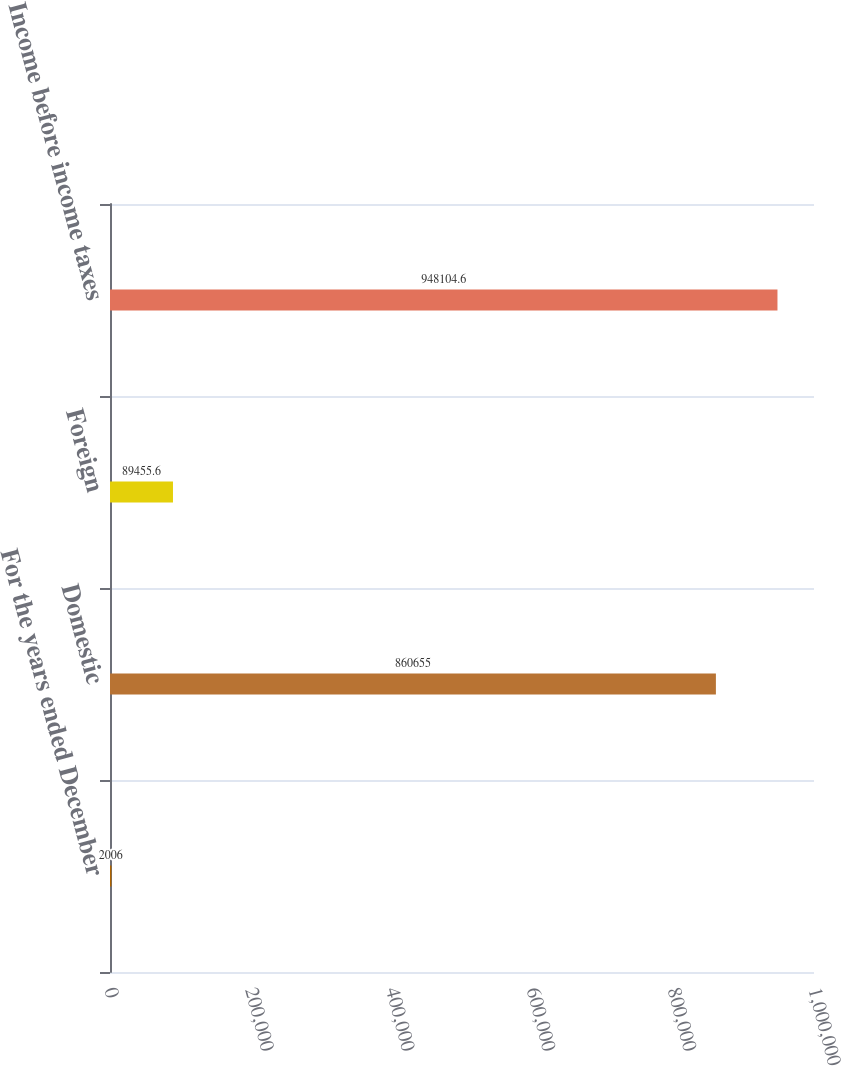Convert chart. <chart><loc_0><loc_0><loc_500><loc_500><bar_chart><fcel>For the years ended December<fcel>Domestic<fcel>Foreign<fcel>Income before income taxes<nl><fcel>2006<fcel>860655<fcel>89455.6<fcel>948105<nl></chart> 